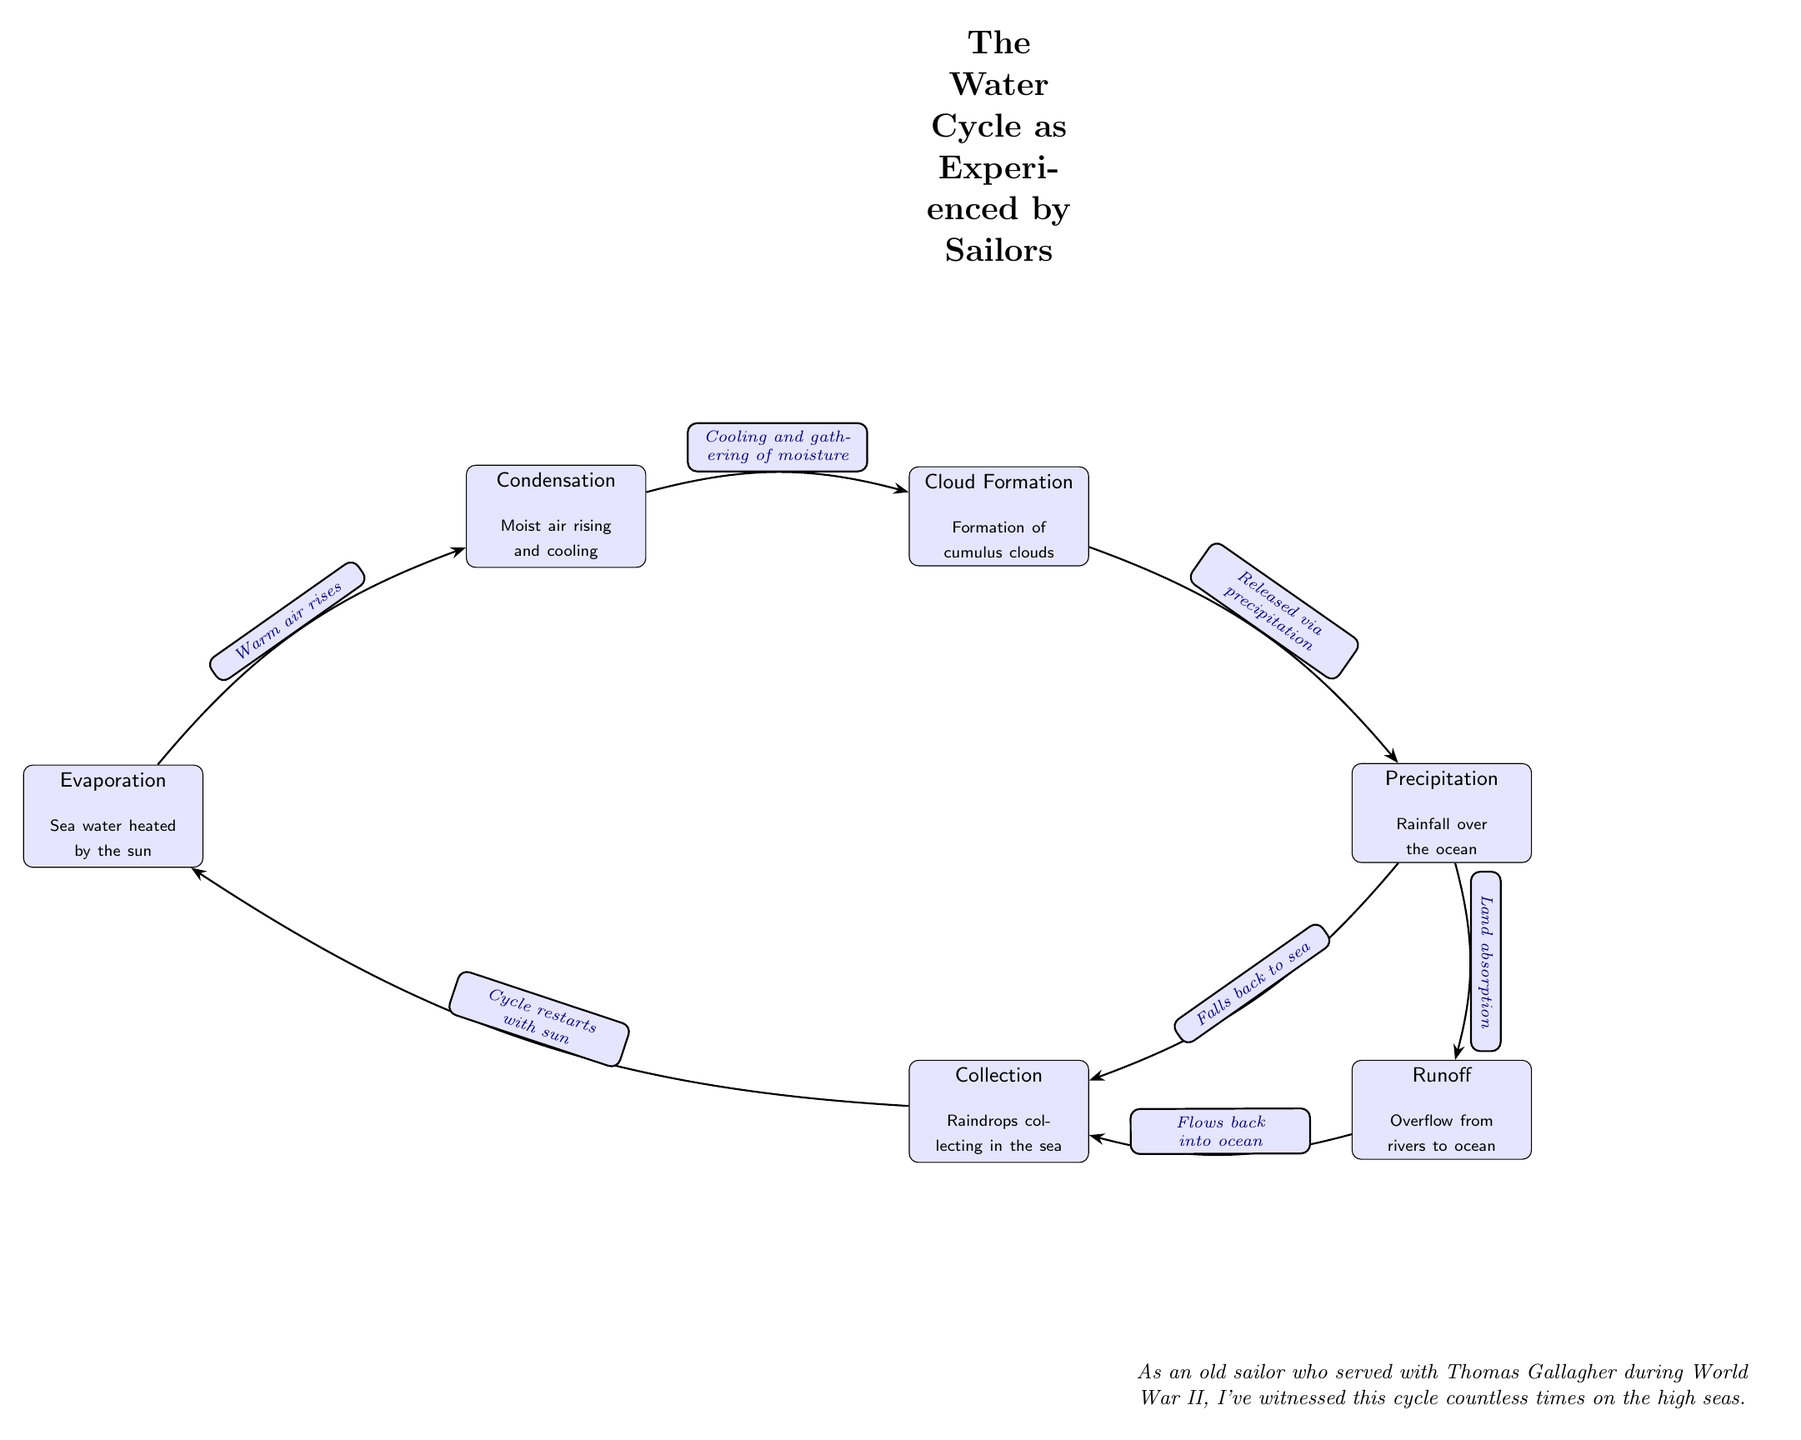What is the first step in the water cycle? The first step in the diagram is "Evaporation," where sea water is heated by the sun, leading to the rise of warm air.
Answer: Evaporation How many nodes are there in the diagram? By counting each labeled section in the diagram, there are a total of six nodes: Evaporation, Condensation, Cloud Formation, Precipitation, Collection, and Runoff.
Answer: Six What process follows condensation? After the condensation process, which involves moist air rising and cooling, the next step is cloud formation where cumulus clouds are created.
Answer: Cloud Formation What do raindrops collect in? The raindrops from precipitation collect back into the sea during the collection phase, as indicated in the flow from precipitation to collection.
Answer: Sea What happens to precipitation that does not fall back into the ocean? The precipitation that does not fall back into the ocean is absorbed by the land, as illustrated by the edge describing "Land absorption" leading to runoff.
Answer: Land absorption What connects cloud formation to precipitation? The connection between cloud formation and precipitation is described by the edge labeled "Released via precipitation," indicating that once clouds form, they eventually result in precipitation.
Answer: Released via precipitation Which two processes are part of the collection phase? The collection phase encompasses both the gathering of raindrops in the sea and the runoff from overflow rivers back to the ocean, representing two integral aspects of water collection.
Answer: Raindrops collecting in the sea; Flows back into ocean What initiates the re-entry of water into the evaporation phase? The cycle restarts with the sun's heating rays, as noted on the arrow connecting collection back to evaporation, illustrating the continuous nature of the water cycle.
Answer: Sun What type of clouds are formed during cloud formation? The clouds formed during the cloud formation process are described as "cumulus clouds," which indicates their specific type and appearance during this stage.
Answer: Cumulus clouds 